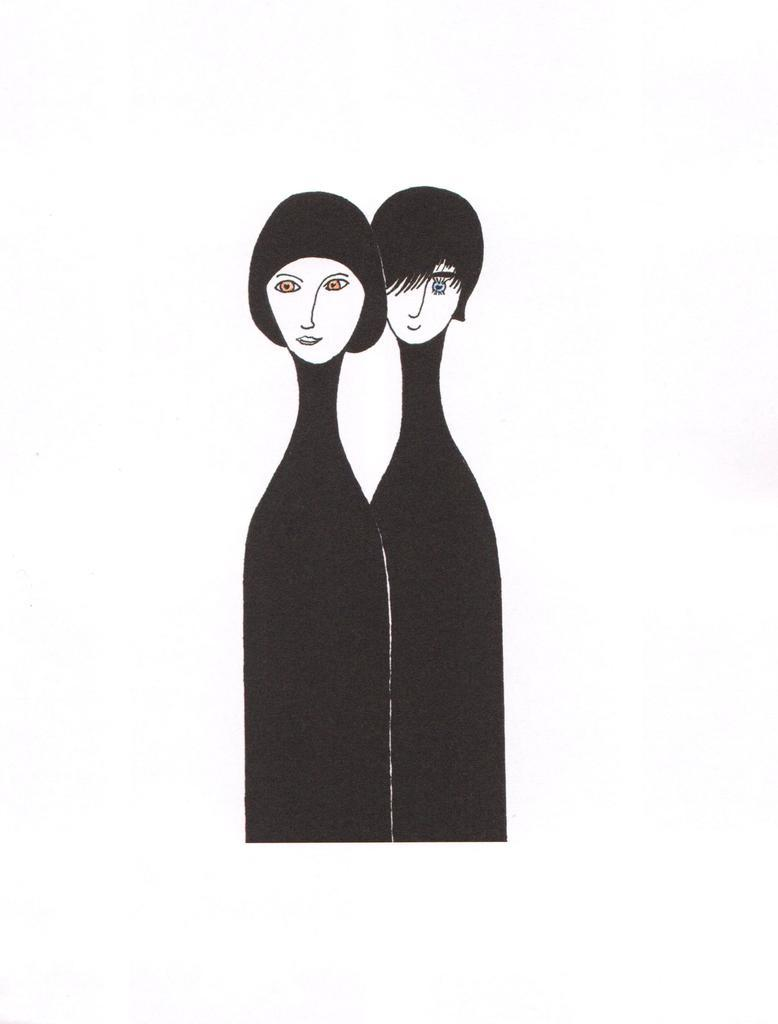What type of image is being shown? The image is an edited picture. What can be seen in the sketch within the image? There is a sketch of two persons in the image. What color is the background of the image? The background of the image is white. What decision did the cow make in the image? There is no cow present in the image, so no decision can be attributed to a cow. 